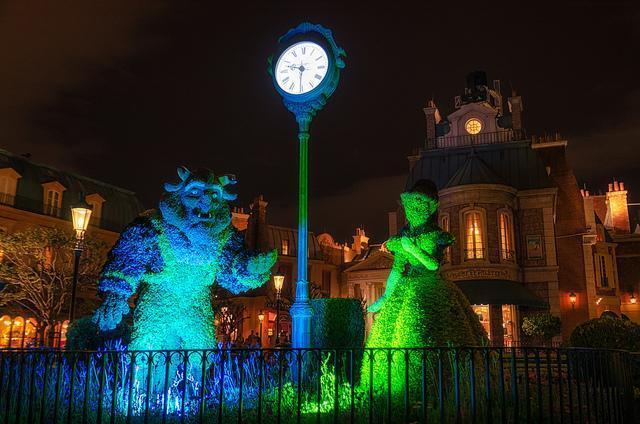How many horses are in this scene?
Give a very brief answer. 0. 